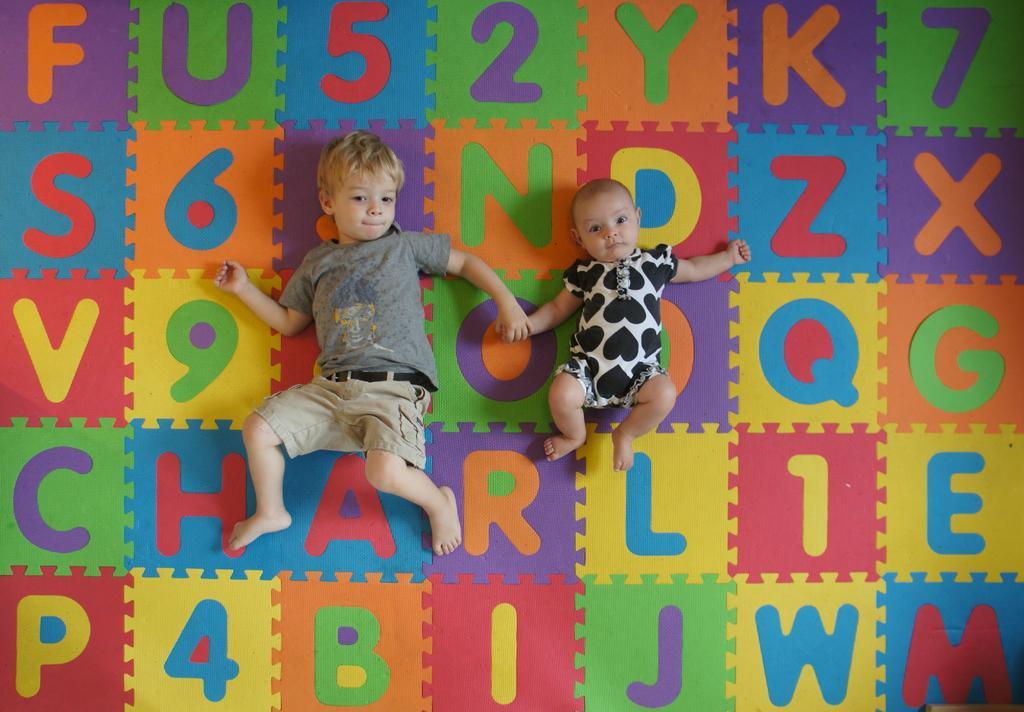In one or two sentences, can you explain what this image depicts? Here we can see two kids laying on the colorful surface with letters. 